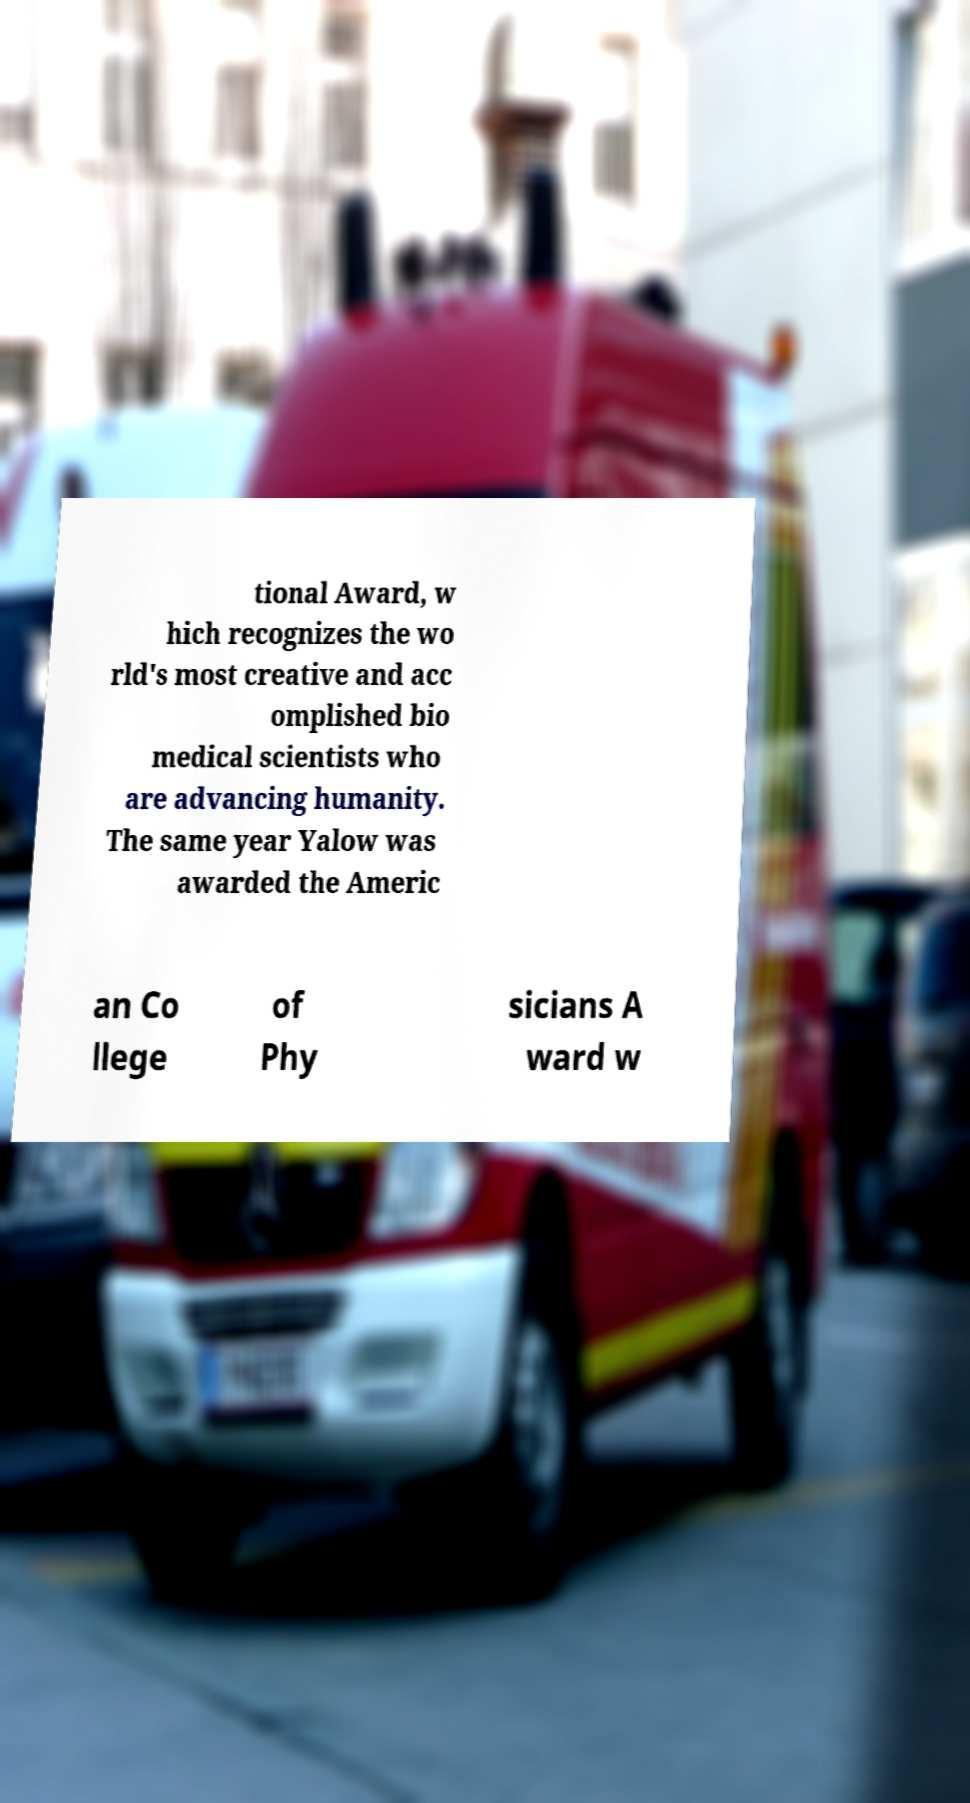Can you accurately transcribe the text from the provided image for me? tional Award, w hich recognizes the wo rld's most creative and acc omplished bio medical scientists who are advancing humanity. The same year Yalow was awarded the Americ an Co llege of Phy sicians A ward w 